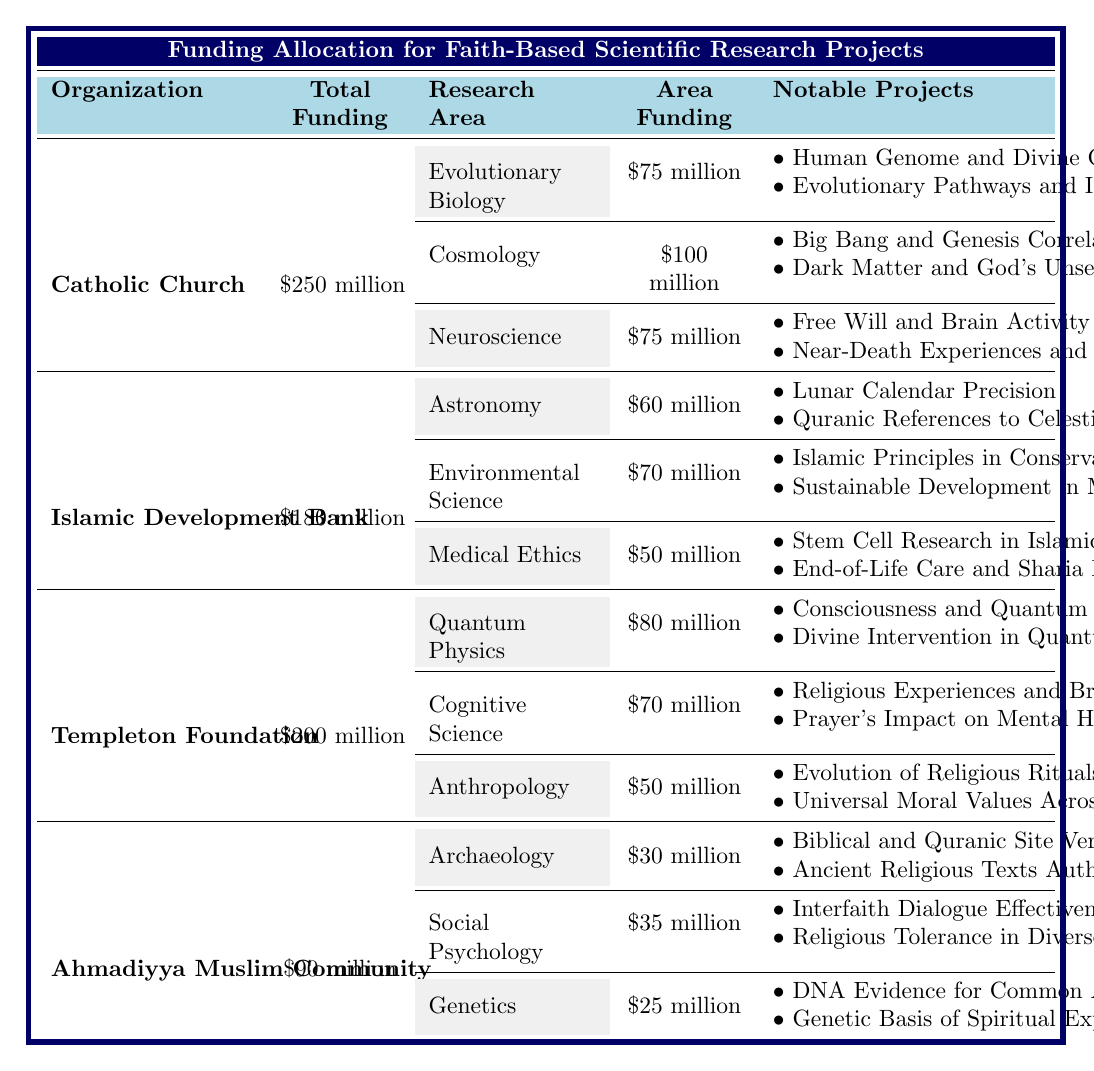What is the total funding allocated by the Catholic Church? The table shows that the Catholic Church has a total funding allocation of $250 million listed directly under the 'Total Funding' column.
Answer: $250 million How much funding is dedicated to Cosmology by the Islamic Development Bank? The Islamic Development Bank does not allocate any funding to Cosmology, as that research area is not listed under their 'Research Areas.'
Answer: $0 million Which organization has allocated the highest amount for Quantum Physics research? The Templeton Foundation has allocated $80 million for Quantum Physics, which is higher than the allocations for this area by other organizations since only one other is listed with an allocation amount (which is none).
Answer: Templeton Foundation What is the total funding for environmental science across all organizations? Referencing the table, we can see that the Islamic Development Bank allocated $70 million for Environmental Science, and no other organizations have allocated funds to this area, summing it to a total of $70 million.
Answer: $70 million Which organization allocated the least amount of funding for Genetics? The Ahmadiyya Muslim Community allocated $25 million for Genetics, which is the only amount listed for this research area since no other organizations have funding listed for Genetics. Thus, it is the least.
Answer: Ahmadiyya Muslim Community What is the difference between the total funding of the Templeton Foundation and the Ahmadiyya Muslim Community? The Templeton Foundation has $200 million, while the Ahmadiyya Muslim Community has $90 million. The difference is $200 million - $90 million = $110 million.
Answer: $110 million Is there any research area funded by the Ahmadiyya Muslim Community that is also funded by the Catholic Church? The table indicates that the research areas for the Ahmadiyya Muslim Community (Archaeology, Social Psychology, and Genetics) do not overlap with the research areas of the Catholic Church (Evolutionary Biology, Cosmology, and Neuroscience). Therefore, there is no overlap in funded research areas.
Answer: No What percentage of the Catholic Church's total funding is allocated to Neuroscience? The funding for Neuroscience is $75 million from a total of $250 million. To find the percentage, we calculate (75 / 250) * 100 = 30%.
Answer: 30% Calculate the total funding allocated to research areas under the Templeton Foundation. The Templeton Foundation allocates $80 million for Quantum Physics, $70 million for Cognitive Science, and $50 million for Anthropology. Adding these amounts together gives $80 million + $70 million + $50 million = $200 million, which matches their total funding.
Answer: $200 million Which notable project from the Catholic Church focuses on near-death experiences? The notable project related to near-death experiences is "Near-Death Experiences and the Soul," listed under the Neuroscience research area of the Catholic Church.
Answer: Near-Death Experiences and the Soul How does the total funding from the Islamic Development Bank compare to the Ahmadiyya Muslim Community? The Islamic Development Bank has total funding of $180 million while the Ahmadiyya Muslim Community has $90 million. The comparison shows that the Islamic Development Bank has $90 million more. Thus, it exceeds the Ahmadiyya Muslim Community's funding.
Answer: Islamic Development Bank has more funding by $90 million 